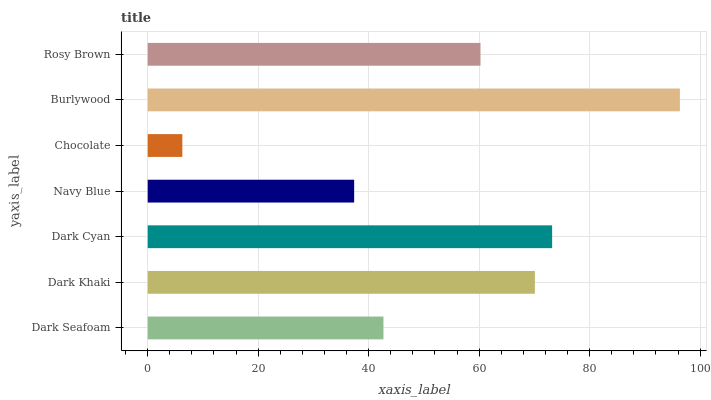Is Chocolate the minimum?
Answer yes or no. Yes. Is Burlywood the maximum?
Answer yes or no. Yes. Is Dark Khaki the minimum?
Answer yes or no. No. Is Dark Khaki the maximum?
Answer yes or no. No. Is Dark Khaki greater than Dark Seafoam?
Answer yes or no. Yes. Is Dark Seafoam less than Dark Khaki?
Answer yes or no. Yes. Is Dark Seafoam greater than Dark Khaki?
Answer yes or no. No. Is Dark Khaki less than Dark Seafoam?
Answer yes or no. No. Is Rosy Brown the high median?
Answer yes or no. Yes. Is Rosy Brown the low median?
Answer yes or no. Yes. Is Chocolate the high median?
Answer yes or no. No. Is Burlywood the low median?
Answer yes or no. No. 